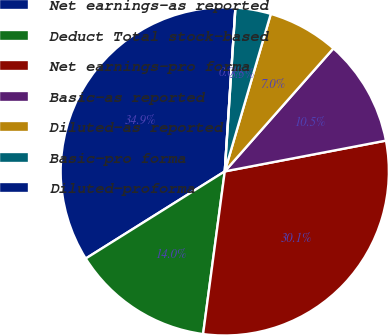Convert chart. <chart><loc_0><loc_0><loc_500><loc_500><pie_chart><fcel>Net earnings-as reported<fcel>Deduct Total stock-based<fcel>Net earnings-pro forma<fcel>Basic-as reported<fcel>Diluted-as reported<fcel>Basic-pro forma<fcel>Diluted-proforma<nl><fcel>34.94%<fcel>13.98%<fcel>30.11%<fcel>10.48%<fcel>6.99%<fcel>3.49%<fcel>0.0%<nl></chart> 